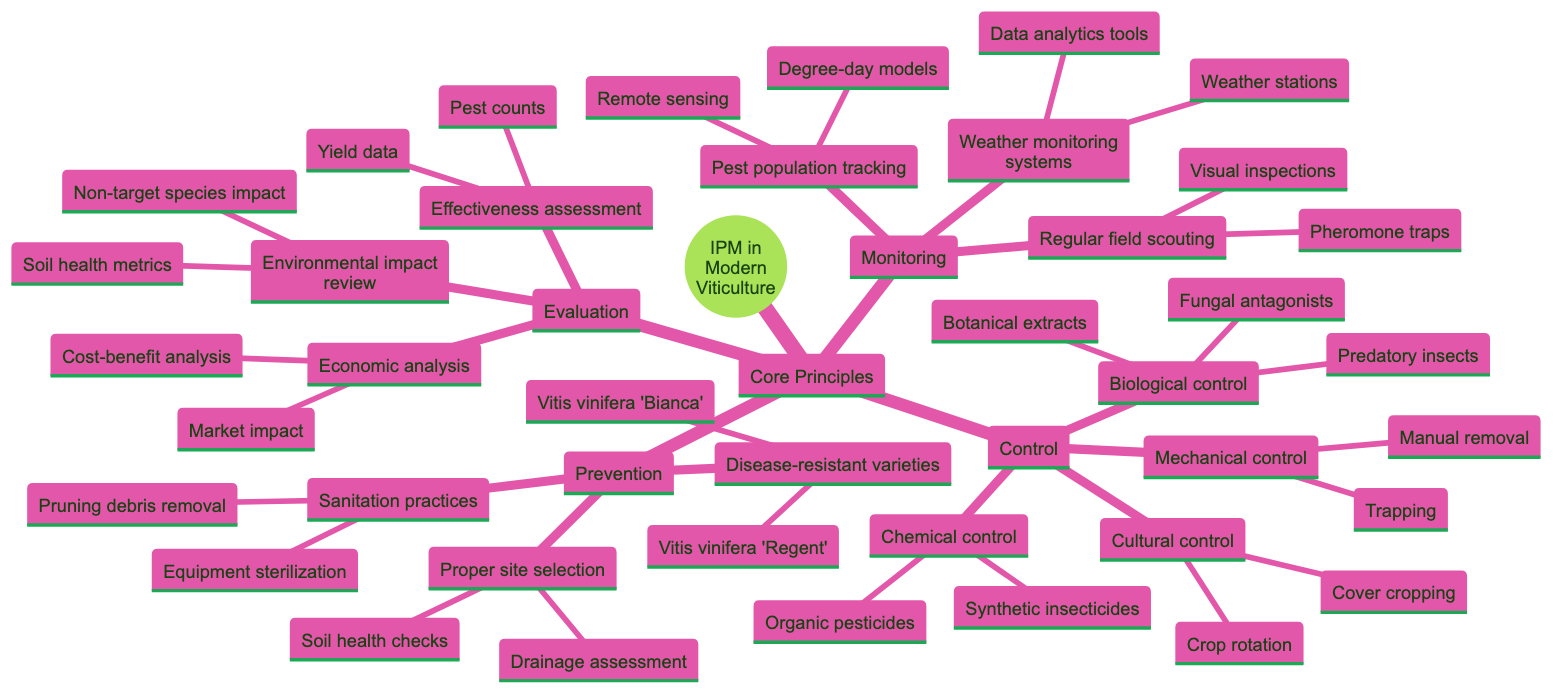What are the core principles of integrated pest management in modern viticulture? The core principles are Prevention, Monitoring, Control, and Evaluation. Each principle represents a key component of integrated pest management.
Answer: Prevention, Monitoring, Control, Evaluation How many examples of disease-resistant grape varieties are listed under Prevention? There are two specific examples listed under Disease-resistant grape varieties: Vitis vinifera 'Regent' and Vitis vinifera 'Bianca'. Therefore, the count is 2.
Answer: 2 What type of control involves the use of predatory insects? Predatory insects are categorized under Biological control, which aims to manage pest populations through natural predators or other biological means.
Answer: Biological control Which component of Integrated Pest Management includes weather monitoring systems? Monitoring includes weather monitoring systems, as it is essential for understanding environmental conditions that affect pest populations.
Answer: Monitoring What is one aspect assessed in the evaluation of integrated pest management strategies? One aspect evaluated is Effectiveness assessment, which involves analyzing pest counts and yield data to determine how well the strategies are working.
Answer: Effectiveness assessment How many control strategies are mentioned in the diagram? There are four distinct control strategies mentioned: Biological control, Chemical control, Cultural control, and Mechanical control, resulting in a total of 4 strategies.
Answer: 4 What is a method for pest population tracking listed in the Monitoring section? Degree-day models are one method listed for tracking pest populations, helping to predict pest life cycles based on temperature data.
Answer: Degree-day models What sanitation practice involves managing debris after pruning? Pruning debris removal is a specific sanitation practice that focuses on clearing plant material to reduce pest and disease risks in the vineyard.
Answer: Pruning debris removal What is a cultural control method in the Control category? Crop rotation is identified as a cultural control method, which helps disrupt pest life cycles by alternating the type of crops grown in a field.
Answer: Crop rotation 